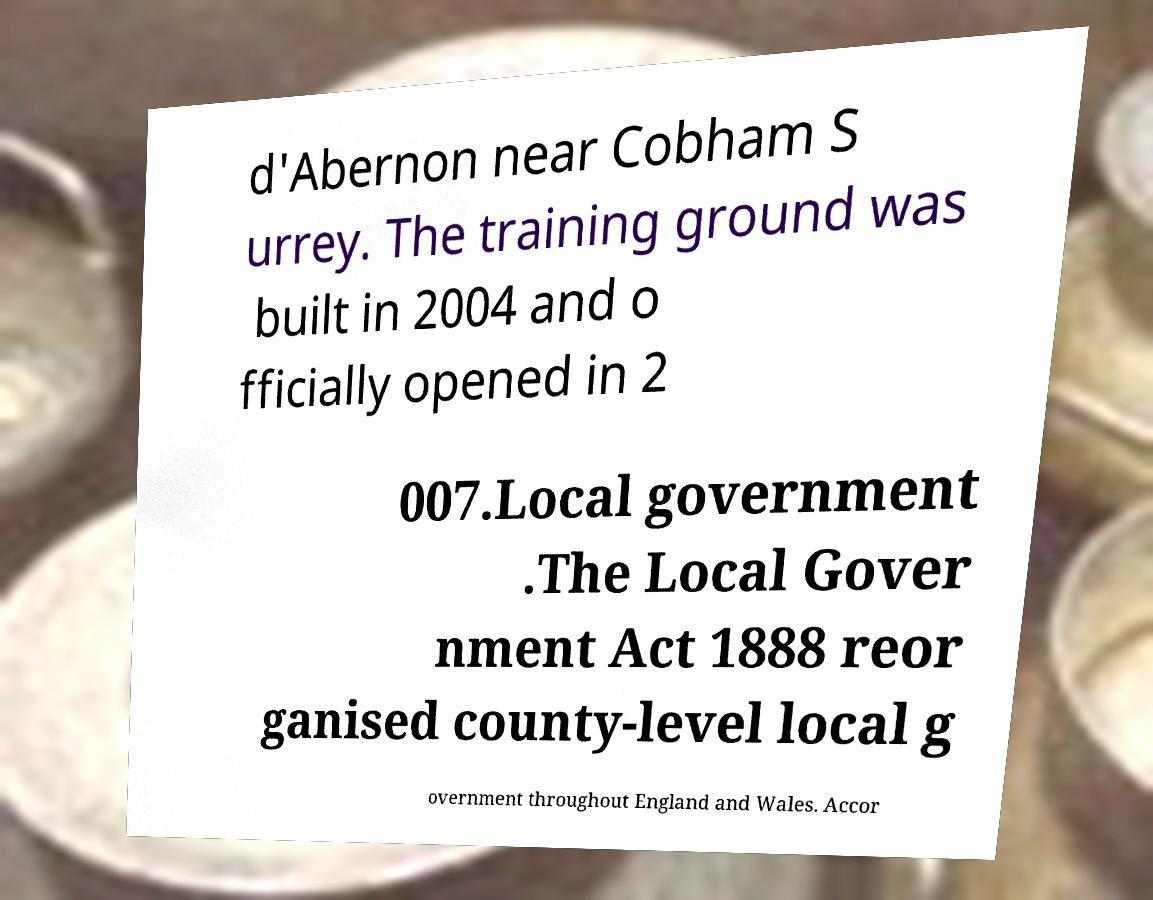I need the written content from this picture converted into text. Can you do that? d'Abernon near Cobham S urrey. The training ground was built in 2004 and o fficially opened in 2 007.Local government .The Local Gover nment Act 1888 reor ganised county-level local g overnment throughout England and Wales. Accor 